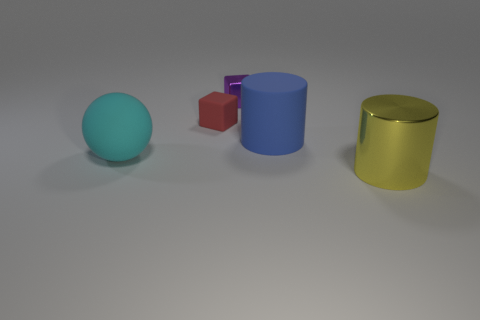Add 4 tiny red metal blocks. How many objects exist? 9 Subtract all balls. How many objects are left? 4 Subtract 1 cyan spheres. How many objects are left? 4 Subtract all big blue matte cylinders. Subtract all yellow cylinders. How many objects are left? 3 Add 1 yellow objects. How many yellow objects are left? 2 Add 4 big cyan shiny spheres. How many big cyan shiny spheres exist? 4 